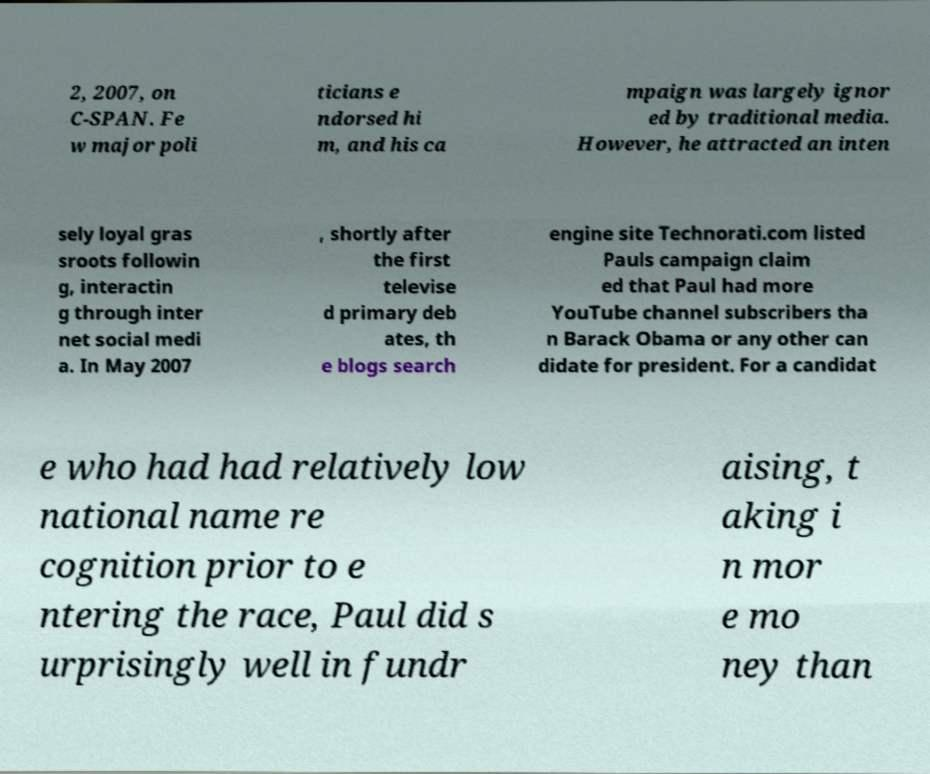There's text embedded in this image that I need extracted. Can you transcribe it verbatim? 2, 2007, on C-SPAN. Fe w major poli ticians e ndorsed hi m, and his ca mpaign was largely ignor ed by traditional media. However, he attracted an inten sely loyal gras sroots followin g, interactin g through inter net social medi a. In May 2007 , shortly after the first televise d primary deb ates, th e blogs search engine site Technorati.com listed Pauls campaign claim ed that Paul had more YouTube channel subscribers tha n Barack Obama or any other can didate for president. For a candidat e who had had relatively low national name re cognition prior to e ntering the race, Paul did s urprisingly well in fundr aising, t aking i n mor e mo ney than 